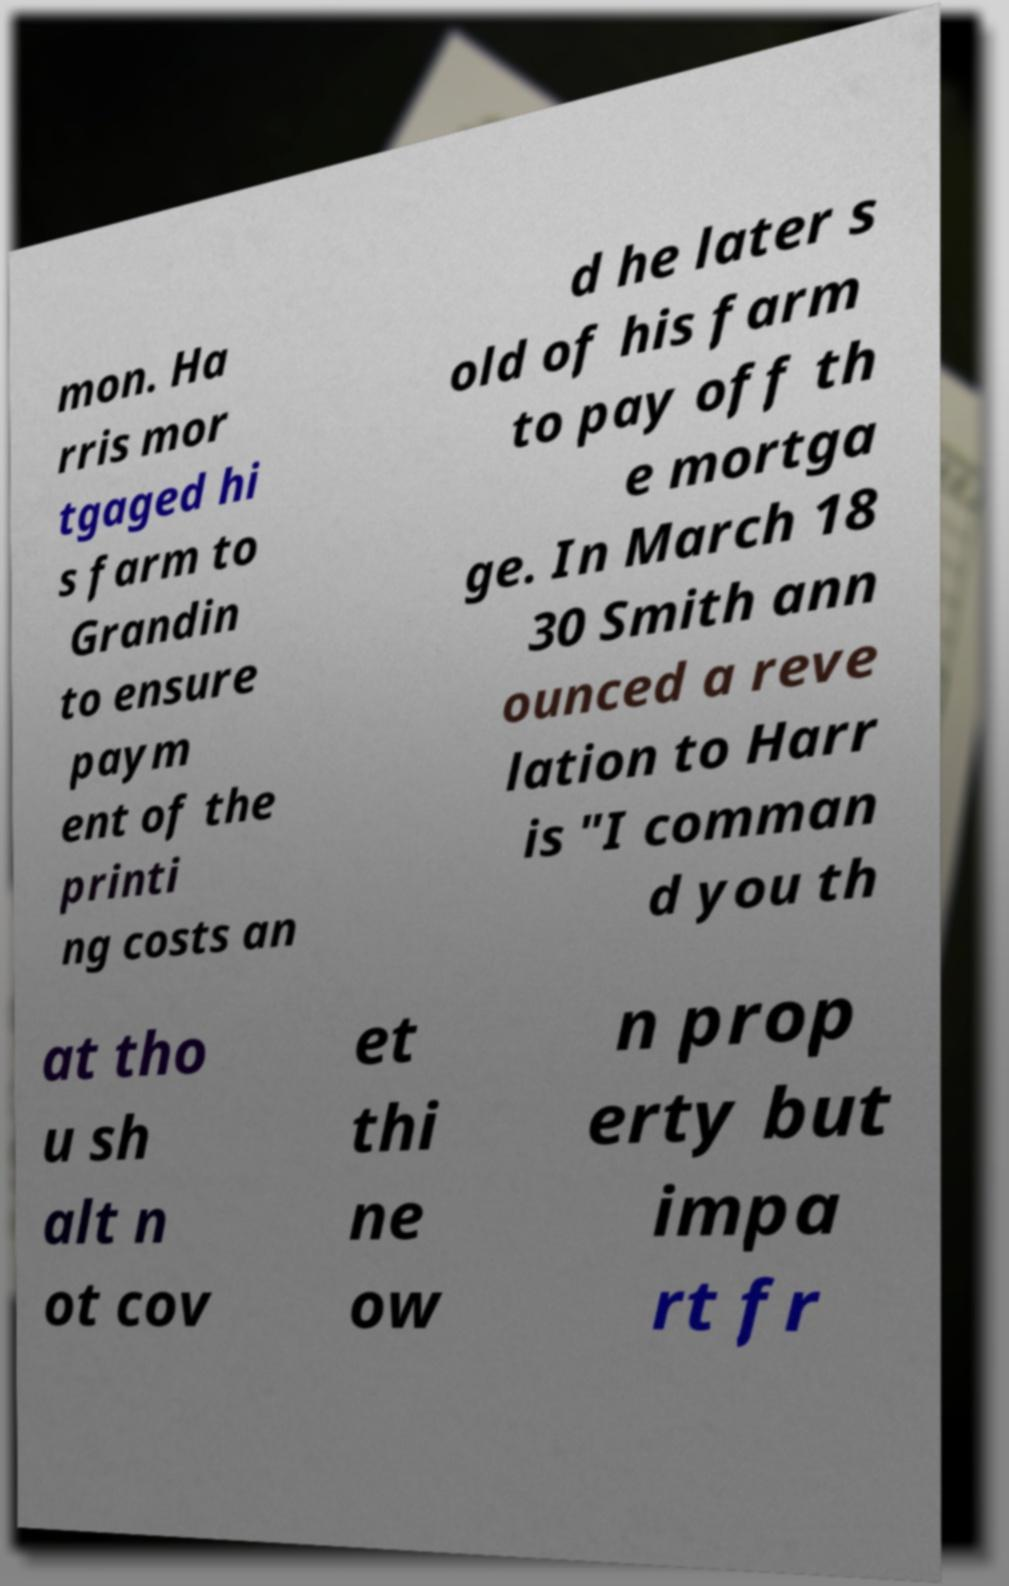Could you extract and type out the text from this image? mon. Ha rris mor tgaged hi s farm to Grandin to ensure paym ent of the printi ng costs an d he later s old of his farm to pay off th e mortga ge. In March 18 30 Smith ann ounced a reve lation to Harr is "I comman d you th at tho u sh alt n ot cov et thi ne ow n prop erty but impa rt fr 